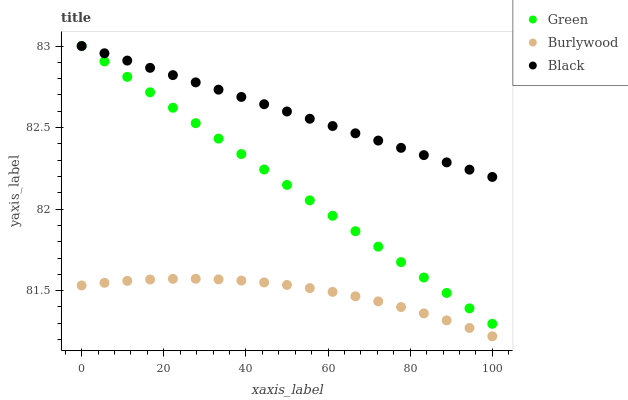Does Burlywood have the minimum area under the curve?
Answer yes or no. Yes. Does Black have the maximum area under the curve?
Answer yes or no. Yes. Does Green have the minimum area under the curve?
Answer yes or no. No. Does Green have the maximum area under the curve?
Answer yes or no. No. Is Green the smoothest?
Answer yes or no. Yes. Is Burlywood the roughest?
Answer yes or no. Yes. Is Black the smoothest?
Answer yes or no. No. Is Black the roughest?
Answer yes or no. No. Does Burlywood have the lowest value?
Answer yes or no. Yes. Does Green have the lowest value?
Answer yes or no. No. Does Green have the highest value?
Answer yes or no. Yes. Is Burlywood less than Green?
Answer yes or no. Yes. Is Green greater than Burlywood?
Answer yes or no. Yes. Does Green intersect Black?
Answer yes or no. Yes. Is Green less than Black?
Answer yes or no. No. Is Green greater than Black?
Answer yes or no. No. Does Burlywood intersect Green?
Answer yes or no. No. 